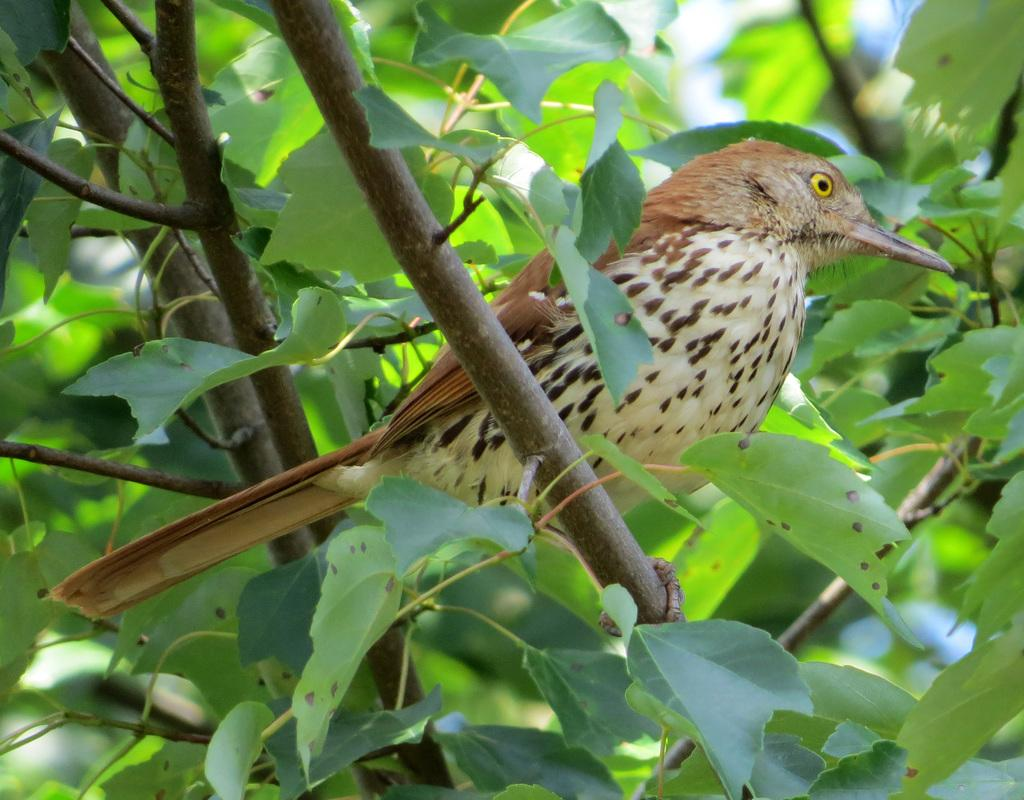What type of animal can be seen in the image? There is a bird in the image. Where is the bird located? The bird is on a tree. What colors can be observed on the bird? The bird has brown and cream colors. What type of ticket does the bird have in its beak? There is no ticket present in the image; the bird is simply perched on a tree. 